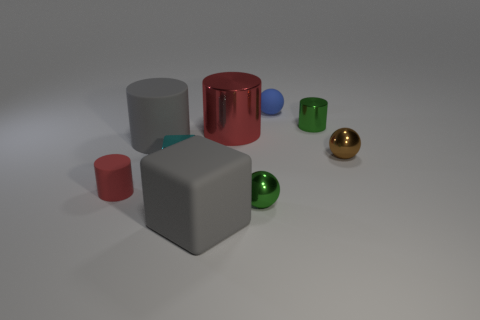Subtract all tiny green metal spheres. How many spheres are left? 2 Add 1 big red shiny cylinders. How many objects exist? 10 Subtract all green cylinders. How many cylinders are left? 3 Subtract all brown balls. How many red cylinders are left? 2 Subtract 1 cylinders. How many cylinders are left? 3 Subtract all cubes. How many objects are left? 7 Subtract all purple cubes. Subtract all green cylinders. How many cubes are left? 2 Subtract all metallic balls. Subtract all red matte objects. How many objects are left? 6 Add 7 big things. How many big things are left? 10 Add 6 gray rubber things. How many gray rubber things exist? 8 